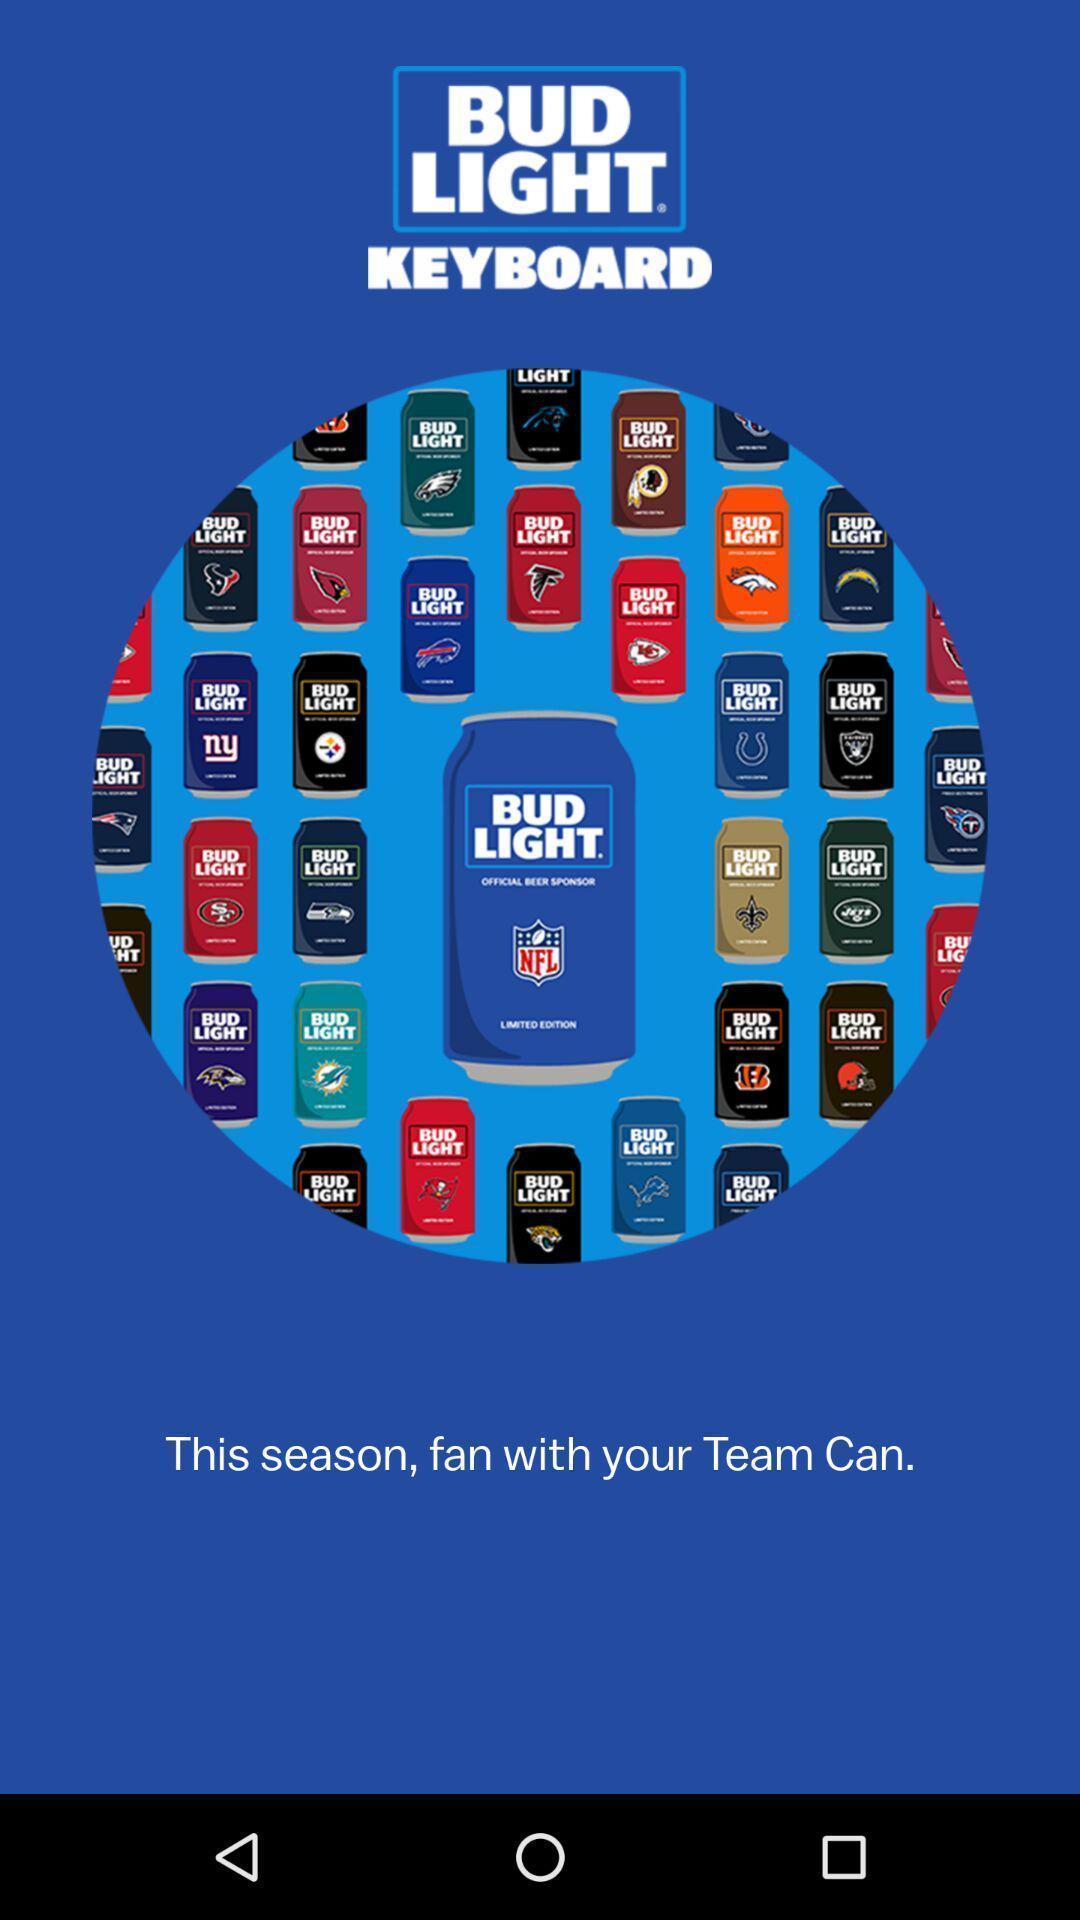Please provide a description for this image. Welcome page of an sports application. 